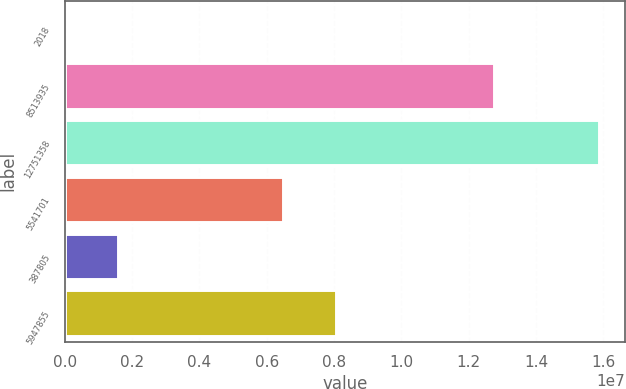Convert chart. <chart><loc_0><loc_0><loc_500><loc_500><bar_chart><fcel>2018<fcel>8513935<fcel>12751358<fcel>5541701<fcel>387805<fcel>5947855<nl><fcel>2016<fcel>1.27433e+07<fcel>1.58578e+07<fcel>6.48167e+06<fcel>1.58759e+06<fcel>8.06724e+06<nl></chart> 